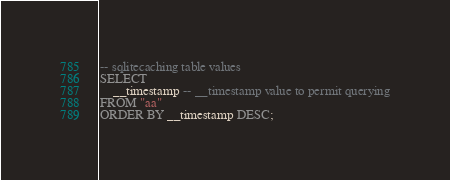<code> <loc_0><loc_0><loc_500><loc_500><_SQL_>-- sqlitecaching table values
SELECT
    __timestamp -- __timestamp value to permit querying
FROM "aa"
ORDER BY __timestamp DESC;
</code> 